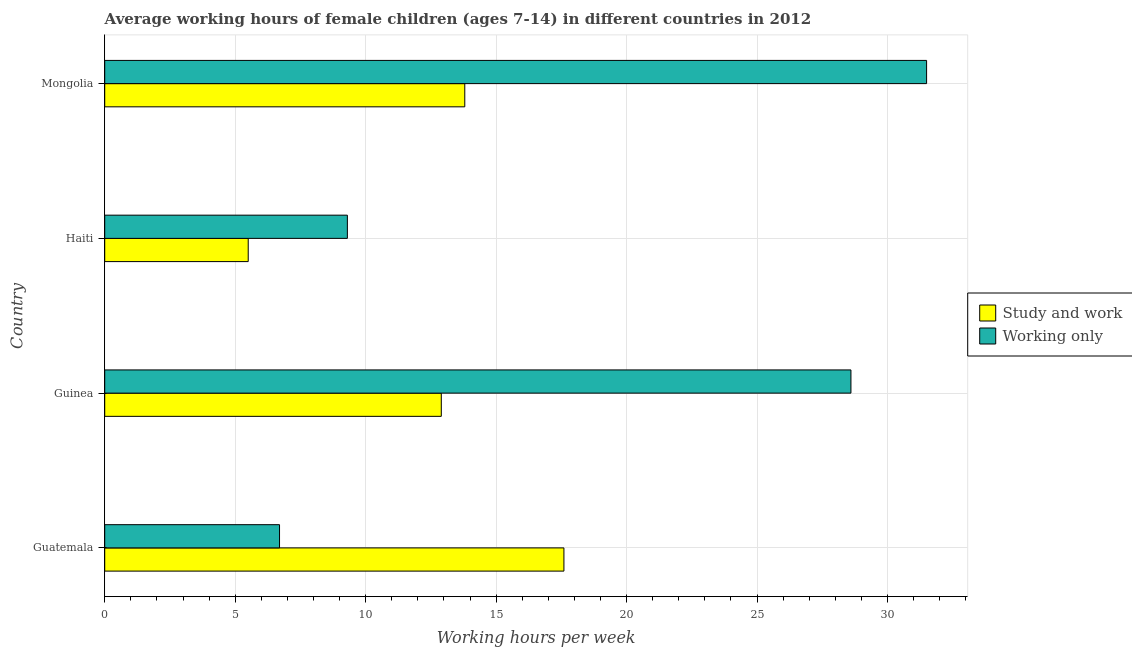How many different coloured bars are there?
Your answer should be compact. 2. Are the number of bars per tick equal to the number of legend labels?
Provide a succinct answer. Yes. Are the number of bars on each tick of the Y-axis equal?
Your response must be concise. Yes. What is the label of the 1st group of bars from the top?
Make the answer very short. Mongolia. What is the average working hour of children involved in only work in Mongolia?
Give a very brief answer. 31.5. Across all countries, what is the minimum average working hour of children involved in study and work?
Ensure brevity in your answer.  5.5. In which country was the average working hour of children involved in study and work maximum?
Offer a very short reply. Guatemala. In which country was the average working hour of children involved in only work minimum?
Make the answer very short. Guatemala. What is the total average working hour of children involved in study and work in the graph?
Keep it short and to the point. 49.8. What is the difference between the average working hour of children involved in only work in Guatemala and that in Mongolia?
Keep it short and to the point. -24.8. What is the difference between the average working hour of children involved in study and work in Mongolia and the average working hour of children involved in only work in Haiti?
Ensure brevity in your answer.  4.5. What is the average average working hour of children involved in only work per country?
Keep it short and to the point. 19.02. What is the difference between the average working hour of children involved in study and work and average working hour of children involved in only work in Guinea?
Your answer should be very brief. -15.7. In how many countries, is the average working hour of children involved in only work greater than 10 hours?
Your response must be concise. 2. What is the ratio of the average working hour of children involved in study and work in Guatemala to that in Mongolia?
Ensure brevity in your answer.  1.27. Is the average working hour of children involved in study and work in Guatemala less than that in Guinea?
Offer a terse response. No. Is the difference between the average working hour of children involved in study and work in Guatemala and Guinea greater than the difference between the average working hour of children involved in only work in Guatemala and Guinea?
Your answer should be compact. Yes. What is the difference between the highest and the second highest average working hour of children involved in study and work?
Your answer should be compact. 3.8. What is the difference between the highest and the lowest average working hour of children involved in study and work?
Offer a very short reply. 12.1. In how many countries, is the average working hour of children involved in only work greater than the average average working hour of children involved in only work taken over all countries?
Offer a very short reply. 2. What does the 2nd bar from the top in Guatemala represents?
Provide a short and direct response. Study and work. What does the 2nd bar from the bottom in Guinea represents?
Offer a very short reply. Working only. How many bars are there?
Your answer should be compact. 8. Are the values on the major ticks of X-axis written in scientific E-notation?
Your answer should be compact. No. Does the graph contain any zero values?
Ensure brevity in your answer.  No. Does the graph contain grids?
Give a very brief answer. Yes. Where does the legend appear in the graph?
Offer a terse response. Center right. How many legend labels are there?
Offer a terse response. 2. What is the title of the graph?
Keep it short and to the point. Average working hours of female children (ages 7-14) in different countries in 2012. Does "Food and tobacco" appear as one of the legend labels in the graph?
Keep it short and to the point. No. What is the label or title of the X-axis?
Keep it short and to the point. Working hours per week. What is the label or title of the Y-axis?
Your answer should be very brief. Country. What is the Working hours per week in Study and work in Guatemala?
Offer a very short reply. 17.6. What is the Working hours per week of Working only in Guinea?
Your response must be concise. 28.6. What is the Working hours per week in Study and work in Mongolia?
Offer a very short reply. 13.8. What is the Working hours per week in Working only in Mongolia?
Make the answer very short. 31.5. Across all countries, what is the maximum Working hours per week in Study and work?
Your response must be concise. 17.6. Across all countries, what is the maximum Working hours per week of Working only?
Provide a succinct answer. 31.5. What is the total Working hours per week in Study and work in the graph?
Offer a very short reply. 49.8. What is the total Working hours per week in Working only in the graph?
Your answer should be very brief. 76.1. What is the difference between the Working hours per week in Working only in Guatemala and that in Guinea?
Your answer should be compact. -21.9. What is the difference between the Working hours per week of Study and work in Guatemala and that in Haiti?
Offer a very short reply. 12.1. What is the difference between the Working hours per week of Working only in Guatemala and that in Haiti?
Offer a very short reply. -2.6. What is the difference between the Working hours per week of Working only in Guatemala and that in Mongolia?
Your answer should be compact. -24.8. What is the difference between the Working hours per week of Working only in Guinea and that in Haiti?
Your answer should be compact. 19.3. What is the difference between the Working hours per week of Study and work in Guinea and that in Mongolia?
Make the answer very short. -0.9. What is the difference between the Working hours per week in Working only in Guinea and that in Mongolia?
Your answer should be compact. -2.9. What is the difference between the Working hours per week in Working only in Haiti and that in Mongolia?
Your answer should be very brief. -22.2. What is the difference between the Working hours per week of Study and work in Guatemala and the Working hours per week of Working only in Guinea?
Your answer should be compact. -11. What is the difference between the Working hours per week of Study and work in Guatemala and the Working hours per week of Working only in Haiti?
Offer a terse response. 8.3. What is the difference between the Working hours per week of Study and work in Guinea and the Working hours per week of Working only in Mongolia?
Provide a succinct answer. -18.6. What is the average Working hours per week of Study and work per country?
Ensure brevity in your answer.  12.45. What is the average Working hours per week in Working only per country?
Provide a short and direct response. 19.02. What is the difference between the Working hours per week in Study and work and Working hours per week in Working only in Guatemala?
Provide a succinct answer. 10.9. What is the difference between the Working hours per week in Study and work and Working hours per week in Working only in Guinea?
Give a very brief answer. -15.7. What is the difference between the Working hours per week in Study and work and Working hours per week in Working only in Haiti?
Offer a terse response. -3.8. What is the difference between the Working hours per week of Study and work and Working hours per week of Working only in Mongolia?
Make the answer very short. -17.7. What is the ratio of the Working hours per week in Study and work in Guatemala to that in Guinea?
Your response must be concise. 1.36. What is the ratio of the Working hours per week of Working only in Guatemala to that in Guinea?
Offer a very short reply. 0.23. What is the ratio of the Working hours per week in Study and work in Guatemala to that in Haiti?
Your answer should be compact. 3.2. What is the ratio of the Working hours per week of Working only in Guatemala to that in Haiti?
Keep it short and to the point. 0.72. What is the ratio of the Working hours per week of Study and work in Guatemala to that in Mongolia?
Offer a terse response. 1.28. What is the ratio of the Working hours per week in Working only in Guatemala to that in Mongolia?
Your answer should be compact. 0.21. What is the ratio of the Working hours per week in Study and work in Guinea to that in Haiti?
Your answer should be very brief. 2.35. What is the ratio of the Working hours per week in Working only in Guinea to that in Haiti?
Your answer should be very brief. 3.08. What is the ratio of the Working hours per week of Study and work in Guinea to that in Mongolia?
Offer a terse response. 0.93. What is the ratio of the Working hours per week in Working only in Guinea to that in Mongolia?
Make the answer very short. 0.91. What is the ratio of the Working hours per week of Study and work in Haiti to that in Mongolia?
Your response must be concise. 0.4. What is the ratio of the Working hours per week of Working only in Haiti to that in Mongolia?
Provide a short and direct response. 0.3. What is the difference between the highest and the second highest Working hours per week of Study and work?
Your answer should be very brief. 3.8. What is the difference between the highest and the second highest Working hours per week in Working only?
Keep it short and to the point. 2.9. What is the difference between the highest and the lowest Working hours per week of Working only?
Give a very brief answer. 24.8. 